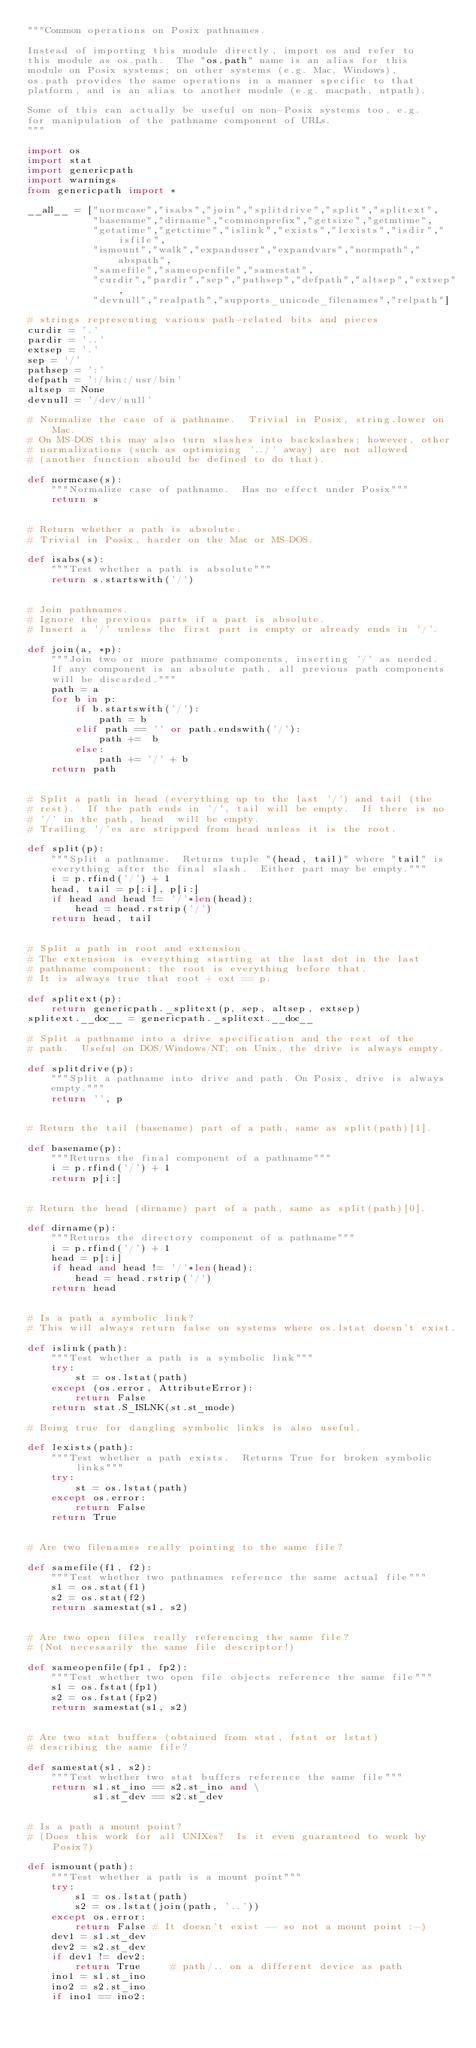<code> <loc_0><loc_0><loc_500><loc_500><_Python_>"""Common operations on Posix pathnames.

Instead of importing this module directly, import os and refer to
this module as os.path.  The "os.path" name is an alias for this
module on Posix systems; on other systems (e.g. Mac, Windows),
os.path provides the same operations in a manner specific to that
platform, and is an alias to another module (e.g. macpath, ntpath).

Some of this can actually be useful on non-Posix systems too, e.g.
for manipulation of the pathname component of URLs.
"""

import os
import stat
import genericpath
import warnings
from genericpath import *

__all__ = ["normcase","isabs","join","splitdrive","split","splitext",
           "basename","dirname","commonprefix","getsize","getmtime",
           "getatime","getctime","islink","exists","lexists","isdir","isfile",
           "ismount","walk","expanduser","expandvars","normpath","abspath",
           "samefile","sameopenfile","samestat",
           "curdir","pardir","sep","pathsep","defpath","altsep","extsep",
           "devnull","realpath","supports_unicode_filenames","relpath"]

# strings representing various path-related bits and pieces
curdir = '.'
pardir = '..'
extsep = '.'
sep = '/'
pathsep = ':'
defpath = ':/bin:/usr/bin'
altsep = None
devnull = '/dev/null'

# Normalize the case of a pathname.  Trivial in Posix, string.lower on Mac.
# On MS-DOS this may also turn slashes into backslashes; however, other
# normalizations (such as optimizing '../' away) are not allowed
# (another function should be defined to do that).

def normcase(s):
    """Normalize case of pathname.  Has no effect under Posix"""
    return s


# Return whether a path is absolute.
# Trivial in Posix, harder on the Mac or MS-DOS.

def isabs(s):
    """Test whether a path is absolute"""
    return s.startswith('/')


# Join pathnames.
# Ignore the previous parts if a part is absolute.
# Insert a '/' unless the first part is empty or already ends in '/'.

def join(a, *p):
    """Join two or more pathname components, inserting '/' as needed.
    If any component is an absolute path, all previous path components
    will be discarded."""
    path = a
    for b in p:
        if b.startswith('/'):
            path = b
        elif path == '' or path.endswith('/'):
            path +=  b
        else:
            path += '/' + b
    return path


# Split a path in head (everything up to the last '/') and tail (the
# rest).  If the path ends in '/', tail will be empty.  If there is no
# '/' in the path, head  will be empty.
# Trailing '/'es are stripped from head unless it is the root.

def split(p):
    """Split a pathname.  Returns tuple "(head, tail)" where "tail" is
    everything after the final slash.  Either part may be empty."""
    i = p.rfind('/') + 1
    head, tail = p[:i], p[i:]
    if head and head != '/'*len(head):
        head = head.rstrip('/')
    return head, tail


# Split a path in root and extension.
# The extension is everything starting at the last dot in the last
# pathname component; the root is everything before that.
# It is always true that root + ext == p.

def splitext(p):
    return genericpath._splitext(p, sep, altsep, extsep)
splitext.__doc__ = genericpath._splitext.__doc__

# Split a pathname into a drive specification and the rest of the
# path.  Useful on DOS/Windows/NT; on Unix, the drive is always empty.

def splitdrive(p):
    """Split a pathname into drive and path. On Posix, drive is always
    empty."""
    return '', p


# Return the tail (basename) part of a path, same as split(path)[1].

def basename(p):
    """Returns the final component of a pathname"""
    i = p.rfind('/') + 1
    return p[i:]


# Return the head (dirname) part of a path, same as split(path)[0].

def dirname(p):
    """Returns the directory component of a pathname"""
    i = p.rfind('/') + 1
    head = p[:i]
    if head and head != '/'*len(head):
        head = head.rstrip('/')
    return head


# Is a path a symbolic link?
# This will always return false on systems where os.lstat doesn't exist.

def islink(path):
    """Test whether a path is a symbolic link"""
    try:
        st = os.lstat(path)
    except (os.error, AttributeError):
        return False
    return stat.S_ISLNK(st.st_mode)

# Being true for dangling symbolic links is also useful.

def lexists(path):
    """Test whether a path exists.  Returns True for broken symbolic links"""
    try:
        st = os.lstat(path)
    except os.error:
        return False
    return True


# Are two filenames really pointing to the same file?

def samefile(f1, f2):
    """Test whether two pathnames reference the same actual file"""
    s1 = os.stat(f1)
    s2 = os.stat(f2)
    return samestat(s1, s2)


# Are two open files really referencing the same file?
# (Not necessarily the same file descriptor!)

def sameopenfile(fp1, fp2):
    """Test whether two open file objects reference the same file"""
    s1 = os.fstat(fp1)
    s2 = os.fstat(fp2)
    return samestat(s1, s2)


# Are two stat buffers (obtained from stat, fstat or lstat)
# describing the same file?

def samestat(s1, s2):
    """Test whether two stat buffers reference the same file"""
    return s1.st_ino == s2.st_ino and \
           s1.st_dev == s2.st_dev


# Is a path a mount point?
# (Does this work for all UNIXes?  Is it even guaranteed to work by Posix?)

def ismount(path):
    """Test whether a path is a mount point"""
    try:
        s1 = os.lstat(path)
        s2 = os.lstat(join(path, '..'))
    except os.error:
        return False # It doesn't exist -- so not a mount point :-)
    dev1 = s1.st_dev
    dev2 = s2.st_dev
    if dev1 != dev2:
        return True     # path/.. on a different device as path
    ino1 = s1.st_ino
    ino2 = s2.st_ino
    if ino1 == ino2:</code> 